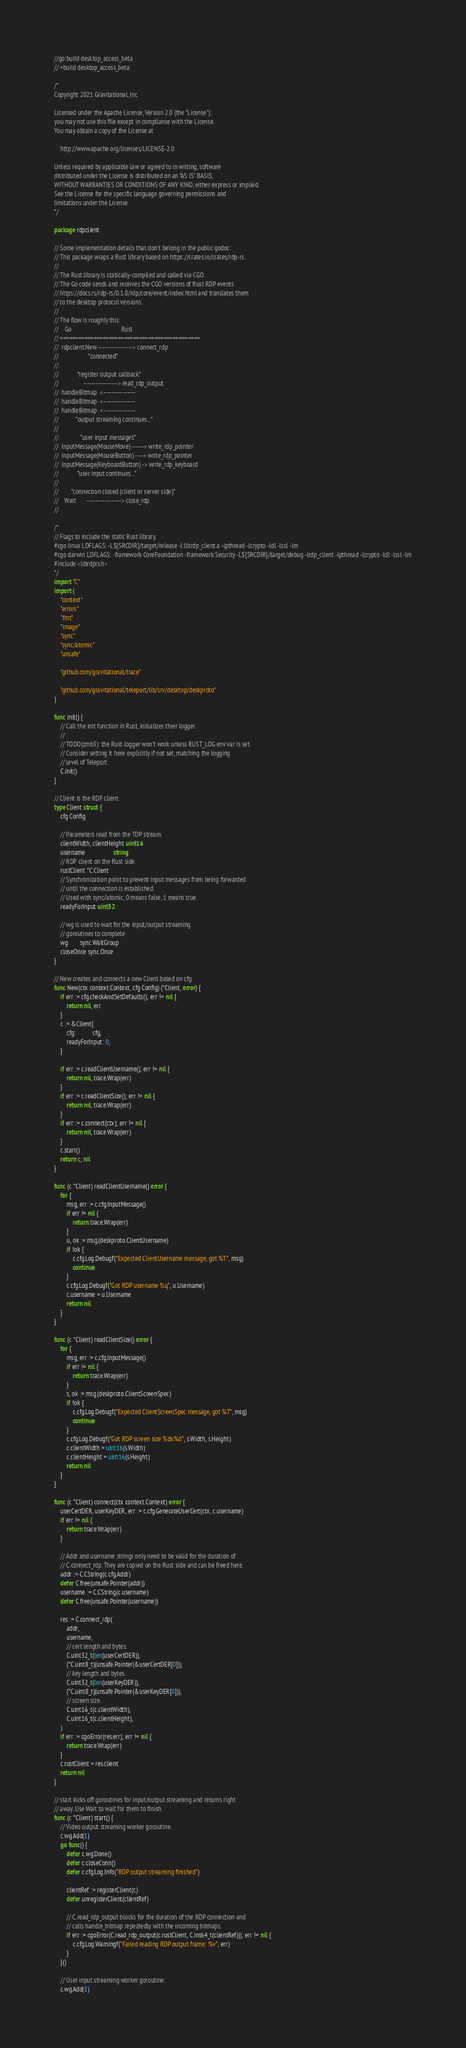Convert code to text. <code><loc_0><loc_0><loc_500><loc_500><_Go_>//go:build desktop_access_beta
// +build desktop_access_beta

/*
Copyright 2021 Gravitational, Inc.

Licensed under the Apache License, Version 2.0 (the "License");
you may not use this file except in compliance with the License.
You may obtain a copy of the License at

    http://www.apache.org/licenses/LICENSE-2.0

Unless required by applicable law or agreed to in writing, software
distributed under the License is distributed on an "AS IS" BASIS,
WITHOUT WARRANTIES OR CONDITIONS OF ANY KIND, either express or implied.
See the License for the specific language governing permissions and
limitations under the License.
*/

package rdpclient

// Some implementation details that don't belong in the public godoc:
// This package wraps a Rust library based on https://crates.io/crates/rdp-rs.
//
// The Rust library is statically-compiled and called via CGO.
// The Go code sends and receives the CGO versions of Rust RDP events
// https://docs.rs/rdp-rs/0.1.0/rdp/core/event/index.html and translates them
// to the desktop protocol versions.
//
// The flow is roughly this:
//    Go                                Rust
// ==============================================
//  rdpclient.New -----------------> connect_rdp
//                   *connected*
//
//            *register output callback*
//                -----------------> read_rdp_output
//  handleBitmap  <----------------
//  handleBitmap  <----------------
//  handleBitmap  <----------------
//           *output streaming continues...*
//
//              *user input messages*
//  InputMessage(MouseMove) ------> write_rdp_pointer
//  InputMessage(MouseButton) ----> write_rdp_pointer
//  InputMessage(KeyboardButton) -> write_rdp_keyboard
//            *user input continues...*
//
//        *connection closed (client or server side)*
//    Wait       -----------------> close_rdp
//

/*
// Flags to include the static Rust library.
#cgo linux LDFLAGS: -L${SRCDIR}/target/release -l:librdp_client.a -lpthread -lcrypto -ldl -lssl -lm
#cgo darwin LDFLAGS: -framework CoreFoundation -framework Security -L${SRCDIR}/target/debug -lrdp_client -lpthread -lcrypto -ldl -lssl -lm
#include <librdprs.h>
*/
import "C"
import (
	"context"
	"errors"
	"fmt"
	"image"
	"sync"
	"sync/atomic"
	"unsafe"

	"github.com/gravitational/trace"

	"github.com/gravitational/teleport/lib/srv/desktop/deskproto"
)

func init() {
	// Call the init function in Rust, initializes their logger.
	//
	// TODO(zmb3): the Rust logger won't work unless RUST_LOG env var is set.
	// Consider setting it here explicitly if not set, matching the logging
	// level of Teleport.
	C.init()
}

// Client is the RDP client.
type Client struct {
	cfg Config

	// Parameters read from the TDP stream.
	clientWidth, clientHeight uint16
	username                  string
	// RDP client on the Rust side.
	rustClient *C.Client
	// Synchronization point to prevent input messages from being forwarded
	// until the connection is established.
	// Used with sync/atomic, 0 means false, 1 means true.
	readyForInput uint32

	// wg is used to wait for the input/output streaming
	// goroutines to complete
	wg        sync.WaitGroup
	closeOnce sync.Once
}

// New creates and connects a new Client based on cfg.
func New(ctx context.Context, cfg Config) (*Client, error) {
	if err := cfg.checkAndSetDefaults(); err != nil {
		return nil, err
	}
	c := &Client{
		cfg:           cfg,
		readyForInput: 0,
	}

	if err := c.readClientUsername(); err != nil {
		return nil, trace.Wrap(err)
	}
	if err := c.readClientSize(); err != nil {
		return nil, trace.Wrap(err)
	}
	if err := c.connect(ctx); err != nil {
		return nil, trace.Wrap(err)
	}
	c.start()
	return c, nil
}

func (c *Client) readClientUsername() error {
	for {
		msg, err := c.cfg.InputMessage()
		if err != nil {
			return trace.Wrap(err)
		}
		u, ok := msg.(deskproto.ClientUsername)
		if !ok {
			c.cfg.Log.Debugf("Expected ClientUsername message, got %T", msg)
			continue
		}
		c.cfg.Log.Debugf("Got RDP username %q", u.Username)
		c.username = u.Username
		return nil
	}
}

func (c *Client) readClientSize() error {
	for {
		msg, err := c.cfg.InputMessage()
		if err != nil {
			return trace.Wrap(err)
		}
		s, ok := msg.(deskproto.ClientScreenSpec)
		if !ok {
			c.cfg.Log.Debugf("Expected ClientScreenSpec message, got %T", msg)
			continue
		}
		c.cfg.Log.Debugf("Got RDP screen size %dx%d", s.Width, s.Height)
		c.clientWidth = uint16(s.Width)
		c.clientHeight = uint16(s.Height)
		return nil
	}
}

func (c *Client) connect(ctx context.Context) error {
	userCertDER, userKeyDER, err := c.cfg.GenerateUserCert(ctx, c.username)
	if err != nil {
		return trace.Wrap(err)
	}

	// Addr and username strings only need to be valid for the duration of
	// C.connect_rdp. They are copied on the Rust side and can be freed here.
	addr := C.CString(c.cfg.Addr)
	defer C.free(unsafe.Pointer(addr))
	username := C.CString(c.username)
	defer C.free(unsafe.Pointer(username))

	res := C.connect_rdp(
		addr,
		username,
		// cert length and bytes.
		C.uint32_t(len(userCertDER)),
		(*C.uint8_t)(unsafe.Pointer(&userCertDER[0])),
		// key length and bytes.
		C.uint32_t(len(userKeyDER)),
		(*C.uint8_t)(unsafe.Pointer(&userKeyDER[0])),
		// screen size.
		C.uint16_t(c.clientWidth),
		C.uint16_t(c.clientHeight),
	)
	if err := cgoError(res.err); err != nil {
		return trace.Wrap(err)
	}
	c.rustClient = res.client
	return nil
}

// start kicks off goroutines for input/output streaming and returns right
// away. Use Wait to wait for them to finish.
func (c *Client) start() {
	// Video output streaming worker goroutine.
	c.wg.Add(1)
	go func() {
		defer c.wg.Done()
		defer c.closeConn()
		defer c.cfg.Log.Info("RDP output streaming finished")

		clientRef := registerClient(c)
		defer unregisterClient(clientRef)

		// C.read_rdp_output blocks for the duration of the RDP connection and
		// calls handle_bitmap repeatedly with the incoming bitmaps.
		if err := cgoError(C.read_rdp_output(c.rustClient, C.int64_t(clientRef))); err != nil {
			c.cfg.Log.Warningf("Failed reading RDP output frame: %v", err)
		}
	}()

	// User input streaming worker goroutine.
	c.wg.Add(1)</code> 